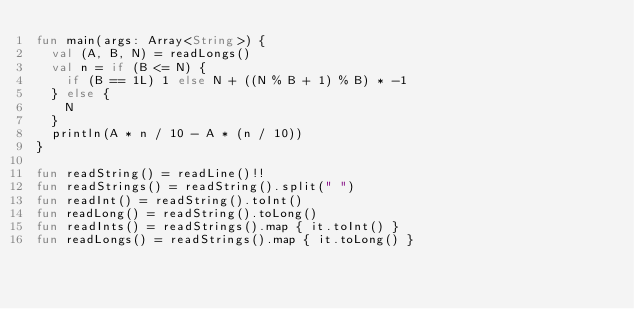Convert code to text. <code><loc_0><loc_0><loc_500><loc_500><_Kotlin_>fun main(args: Array<String>) {
  val (A, B, N) = readLongs()
  val n = if (B <= N) {
    if (B == 1L) 1 else N + ((N % B + 1) % B) * -1
  } else {
    N
  }
  println(A * n / 10 - A * (n / 10))
}

fun readString() = readLine()!!
fun readStrings() = readString().split(" ")
fun readInt() = readString().toInt()
fun readLong() = readString().toLong()
fun readInts() = readStrings().map { it.toInt() }
fun readLongs() = readStrings().map { it.toLong() }
</code> 